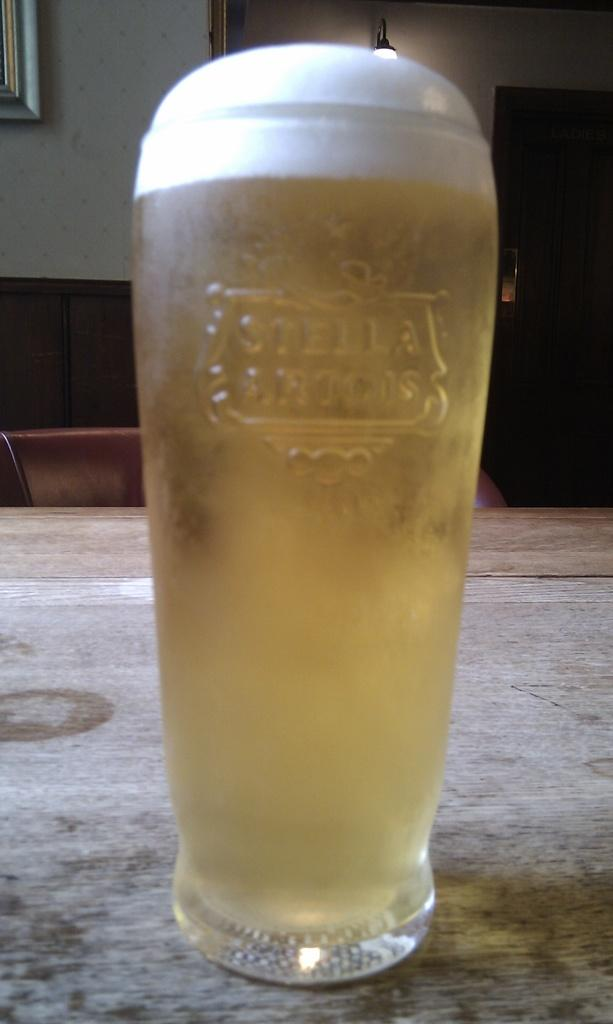<image>
Offer a succinct explanation of the picture presented. Stella branded glass is filled to the brim with beer. 